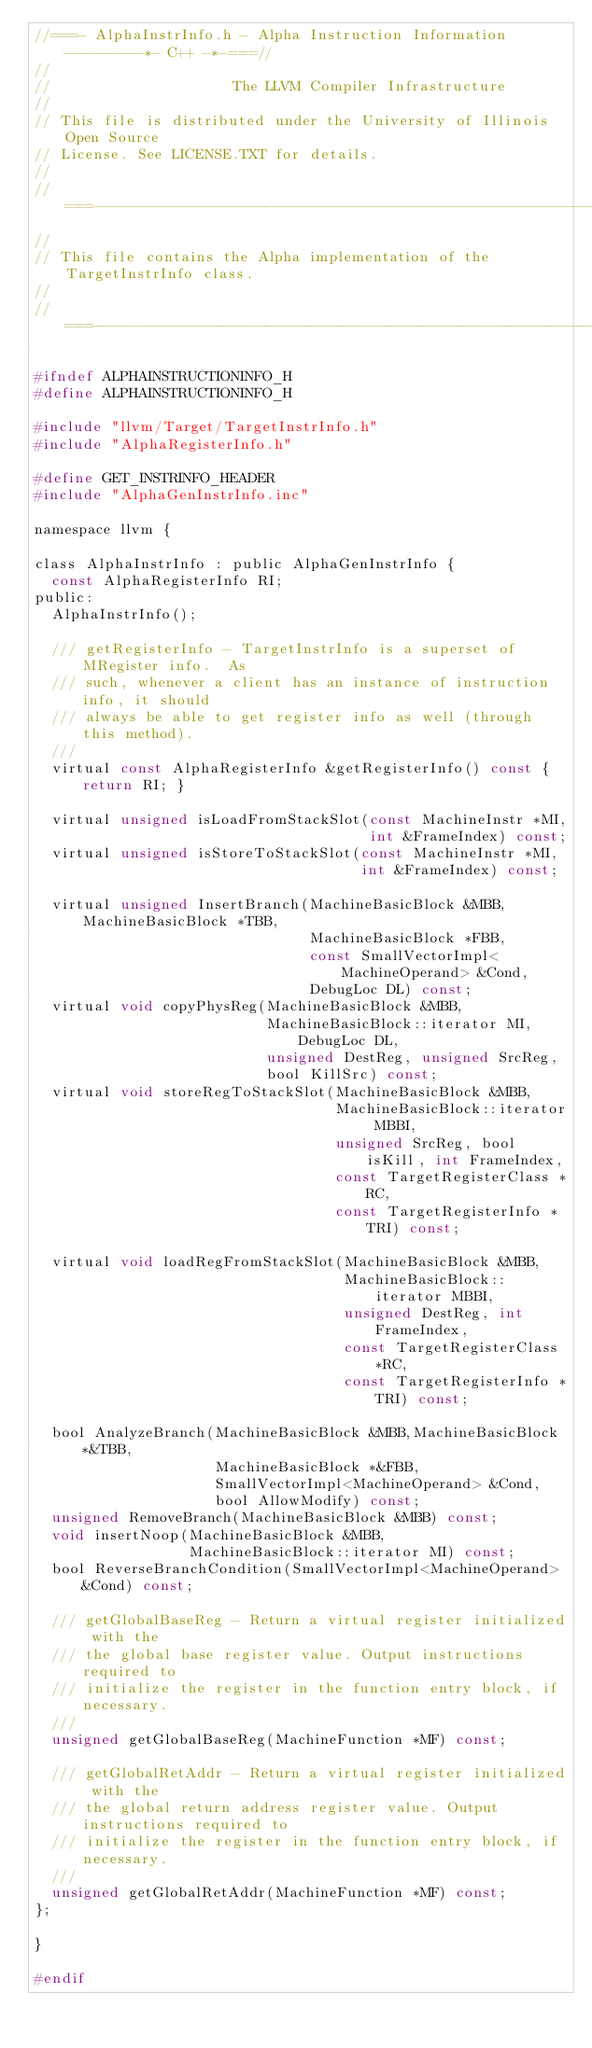<code> <loc_0><loc_0><loc_500><loc_500><_C_>//===- AlphaInstrInfo.h - Alpha Instruction Information ---------*- C++ -*-===//
//
//                     The LLVM Compiler Infrastructure
//
// This file is distributed under the University of Illinois Open Source
// License. See LICENSE.TXT for details.
//
//===----------------------------------------------------------------------===//
//
// This file contains the Alpha implementation of the TargetInstrInfo class.
//
//===----------------------------------------------------------------------===//

#ifndef ALPHAINSTRUCTIONINFO_H
#define ALPHAINSTRUCTIONINFO_H

#include "llvm/Target/TargetInstrInfo.h"
#include "AlphaRegisterInfo.h"

#define GET_INSTRINFO_HEADER
#include "AlphaGenInstrInfo.inc"

namespace llvm {

class AlphaInstrInfo : public AlphaGenInstrInfo {
  const AlphaRegisterInfo RI;
public:
  AlphaInstrInfo();

  /// getRegisterInfo - TargetInstrInfo is a superset of MRegister info.  As
  /// such, whenever a client has an instance of instruction info, it should
  /// always be able to get register info as well (through this method).
  ///
  virtual const AlphaRegisterInfo &getRegisterInfo() const { return RI; }

  virtual unsigned isLoadFromStackSlot(const MachineInstr *MI,
                                       int &FrameIndex) const;
  virtual unsigned isStoreToStackSlot(const MachineInstr *MI,
                                      int &FrameIndex) const;
  
  virtual unsigned InsertBranch(MachineBasicBlock &MBB, MachineBasicBlock *TBB,
                                MachineBasicBlock *FBB,
                                const SmallVectorImpl<MachineOperand> &Cond,
                                DebugLoc DL) const;
  virtual void copyPhysReg(MachineBasicBlock &MBB,
                           MachineBasicBlock::iterator MI, DebugLoc DL,
                           unsigned DestReg, unsigned SrcReg,
                           bool KillSrc) const;
  virtual void storeRegToStackSlot(MachineBasicBlock &MBB,
                                   MachineBasicBlock::iterator MBBI,
                                   unsigned SrcReg, bool isKill, int FrameIndex,
                                   const TargetRegisterClass *RC,
                                   const TargetRegisterInfo *TRI) const;

  virtual void loadRegFromStackSlot(MachineBasicBlock &MBB,
                                    MachineBasicBlock::iterator MBBI,
                                    unsigned DestReg, int FrameIndex,
                                    const TargetRegisterClass *RC,
                                    const TargetRegisterInfo *TRI) const;
  
  bool AnalyzeBranch(MachineBasicBlock &MBB,MachineBasicBlock *&TBB,
                     MachineBasicBlock *&FBB,
                     SmallVectorImpl<MachineOperand> &Cond,
                     bool AllowModify) const;
  unsigned RemoveBranch(MachineBasicBlock &MBB) const;
  void insertNoop(MachineBasicBlock &MBB, 
                  MachineBasicBlock::iterator MI) const;
  bool ReverseBranchCondition(SmallVectorImpl<MachineOperand> &Cond) const;

  /// getGlobalBaseReg - Return a virtual register initialized with the
  /// the global base register value. Output instructions required to
  /// initialize the register in the function entry block, if necessary.
  ///
  unsigned getGlobalBaseReg(MachineFunction *MF) const;

  /// getGlobalRetAddr - Return a virtual register initialized with the
  /// the global return address register value. Output instructions required to
  /// initialize the register in the function entry block, if necessary.
  ///
  unsigned getGlobalRetAddr(MachineFunction *MF) const;
};

}

#endif
</code> 